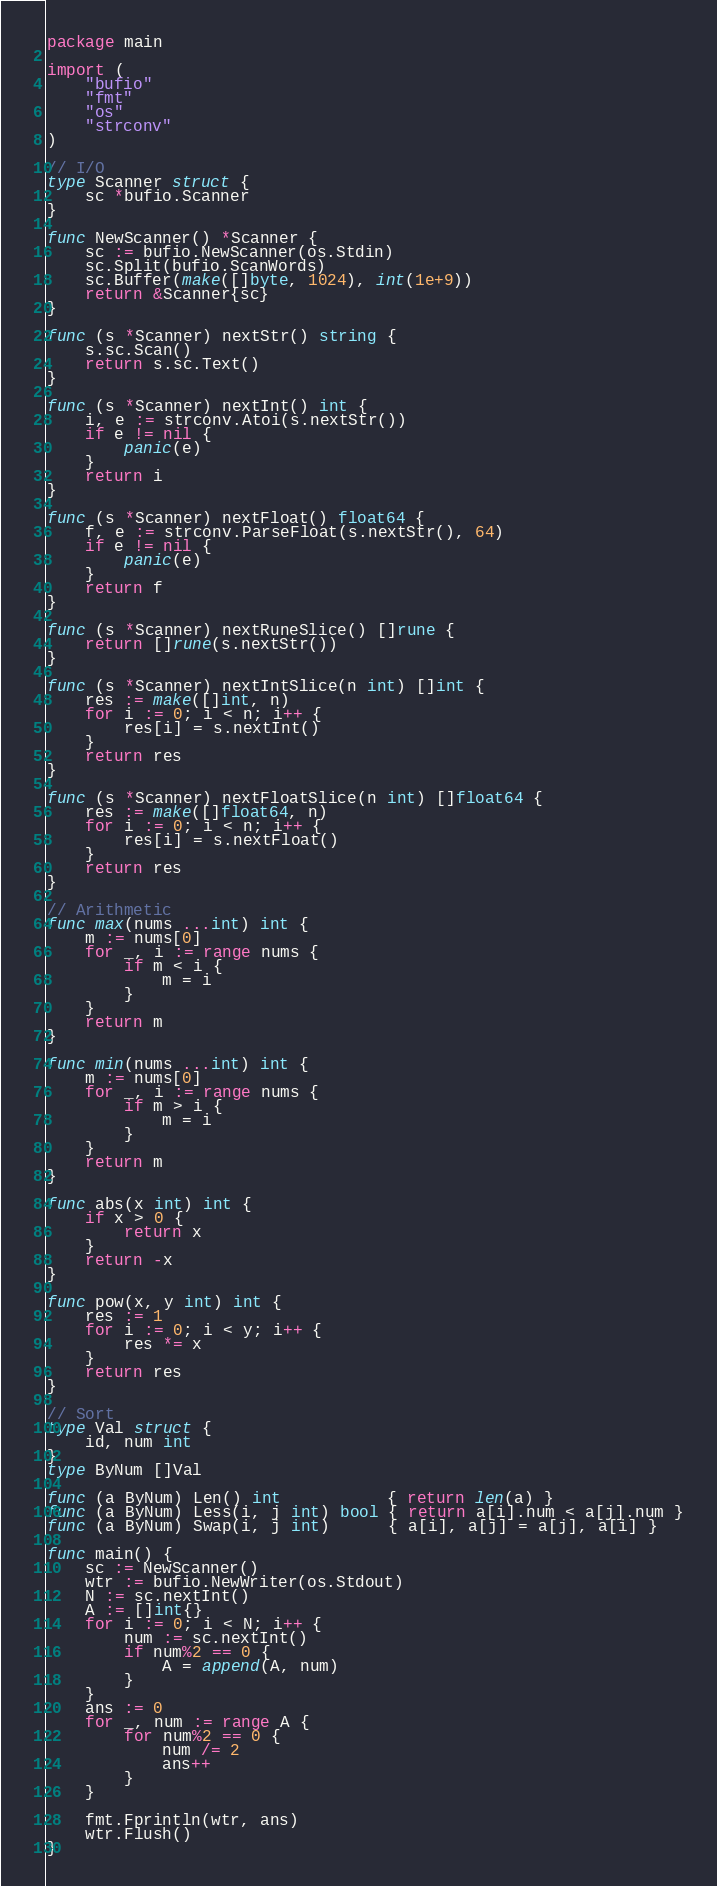<code> <loc_0><loc_0><loc_500><loc_500><_Go_>package main

import (
	"bufio"
	"fmt"
	"os"
	"strconv"
)

// I/O
type Scanner struct {
	sc *bufio.Scanner
}

func NewScanner() *Scanner {
	sc := bufio.NewScanner(os.Stdin)
	sc.Split(bufio.ScanWords)
	sc.Buffer(make([]byte, 1024), int(1e+9))
	return &Scanner{sc}
}

func (s *Scanner) nextStr() string {
	s.sc.Scan()
	return s.sc.Text()
}

func (s *Scanner) nextInt() int {
	i, e := strconv.Atoi(s.nextStr())
	if e != nil {
		panic(e)
	}
	return i
}

func (s *Scanner) nextFloat() float64 {
	f, e := strconv.ParseFloat(s.nextStr(), 64)
	if e != nil {
		panic(e)
	}
	return f
}

func (s *Scanner) nextRuneSlice() []rune {
	return []rune(s.nextStr())
}

func (s *Scanner) nextIntSlice(n int) []int {
	res := make([]int, n)
	for i := 0; i < n; i++ {
		res[i] = s.nextInt()
	}
	return res
}

func (s *Scanner) nextFloatSlice(n int) []float64 {
	res := make([]float64, n)
	for i := 0; i < n; i++ {
		res[i] = s.nextFloat()
	}
	return res
}

// Arithmetic
func max(nums ...int) int {
	m := nums[0]
	for _, i := range nums {
		if m < i {
			m = i
		}
	}
	return m
}

func min(nums ...int) int {
	m := nums[0]
	for _, i := range nums {
		if m > i {
			m = i
		}
	}
	return m
}

func abs(x int) int {
	if x > 0 {
		return x
	}
	return -x
}

func pow(x, y int) int {
	res := 1
	for i := 0; i < y; i++ {
		res *= x
	}
	return res
}

// Sort
type Val struct {
	id, num int
}
type ByNum []Val

func (a ByNum) Len() int           { return len(a) }
func (a ByNum) Less(i, j int) bool { return a[i].num < a[j].num }
func (a ByNum) Swap(i, j int)      { a[i], a[j] = a[j], a[i] }

func main() {
	sc := NewScanner()
	wtr := bufio.NewWriter(os.Stdout)
	N := sc.nextInt()
	A := []int{}
	for i := 0; i < N; i++ {
		num := sc.nextInt()
		if num%2 == 0 {
			A = append(A, num)
		}
	}
	ans := 0
	for _, num := range A {
		for num%2 == 0 {
			num /= 2
			ans++
		}
	}

	fmt.Fprintln(wtr, ans)
	wtr.Flush()
}
</code> 